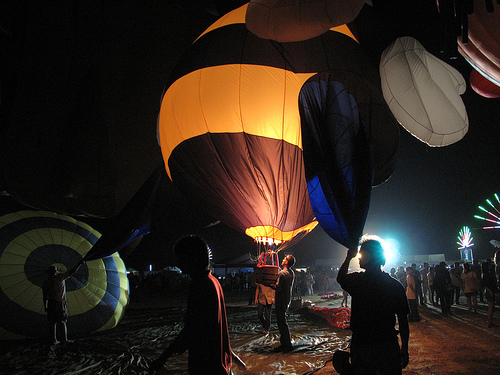<image>
Can you confirm if the man is under the balloon? No. The man is not positioned under the balloon. The vertical relationship between these objects is different. Where is the balloon in relation to the man? Is it in the man? No. The balloon is not contained within the man. These objects have a different spatial relationship. 